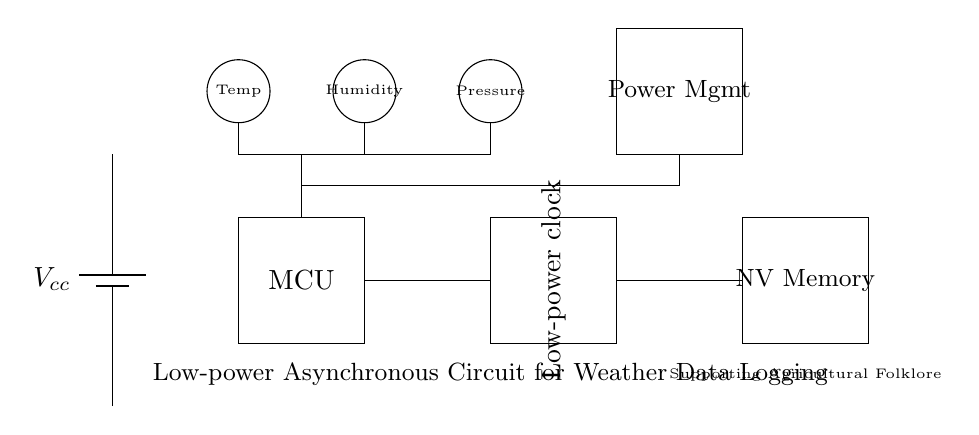What is the supply voltage in this circuit? The circuit has a power supply indicated as a battery symbol marked Vcc, which typically denotes the supply voltage. Since no specific value is given in the diagram, it is assumed as a generic voltage supply.
Answer: Vcc What component is responsible for timekeeping? The circuit diagram shows a box labeled "Low-power clock," which handles timekeeping functions in asynchronous circuits.
Answer: Low-power clock How many sensors are included in the circuit? The diagram illustrates three sensor components: temperature, humidity, and pressure. By counting the circles labeled as sensors, we confirm the total number.
Answer: Three What type of memory is used for data storage? The circuit contains a rectangular box labeled "NV Memory," indicating the use of non-volatile memory, which retains data even without power.
Answer: Non-volatile memory What is the main purpose of this circuit? The diagram includes a label stating "Low-power Asynchronous Circuit for Weather Data Logging," which describes the primary function of the circuit in capturing weather data.
Answer: Weather data logging Explain why the microcontroller is essential in this circuit. In the circuit, the microcontroller (MCU) is crucial as it processes data from the sensors (temperature, humidity, pressure) and manages communication with the non-volatile memory to log the collected weather data over time.
Answer: Data processing What does the power management block do in this circuit? The "Power Mgmt" block manages the power supply to the system components, ensuring low power consumption during operation, particularly important in asynchronous circuits designed for long-term logging without frequent maintenance.
Answer: Power management 